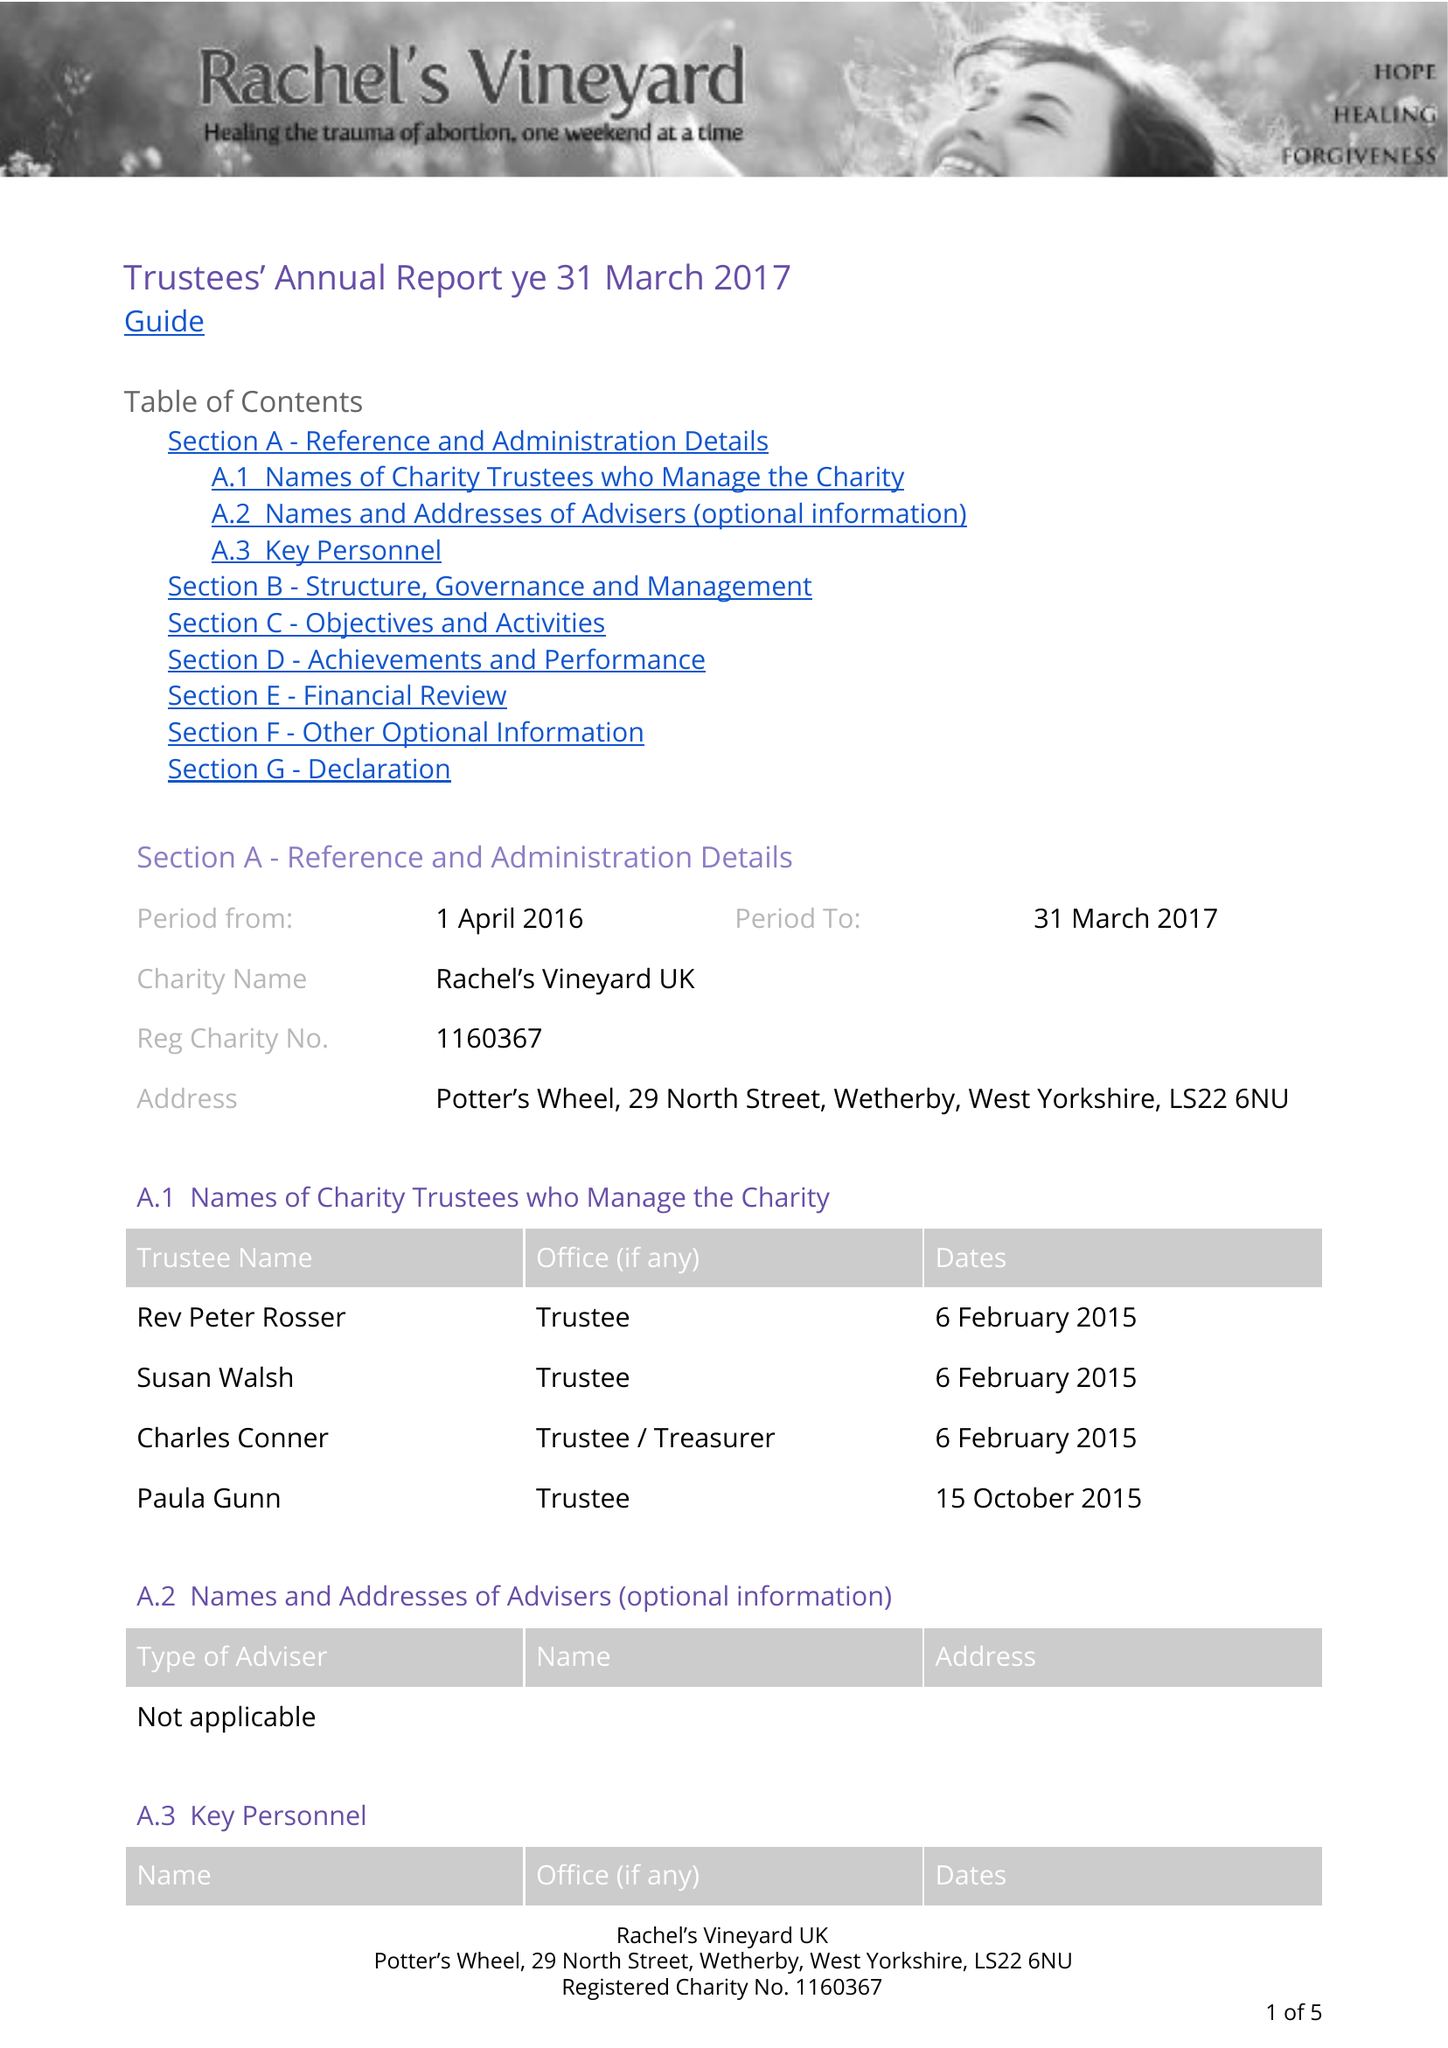What is the value for the address__postcode?
Answer the question using a single word or phrase. LS22 6NX 